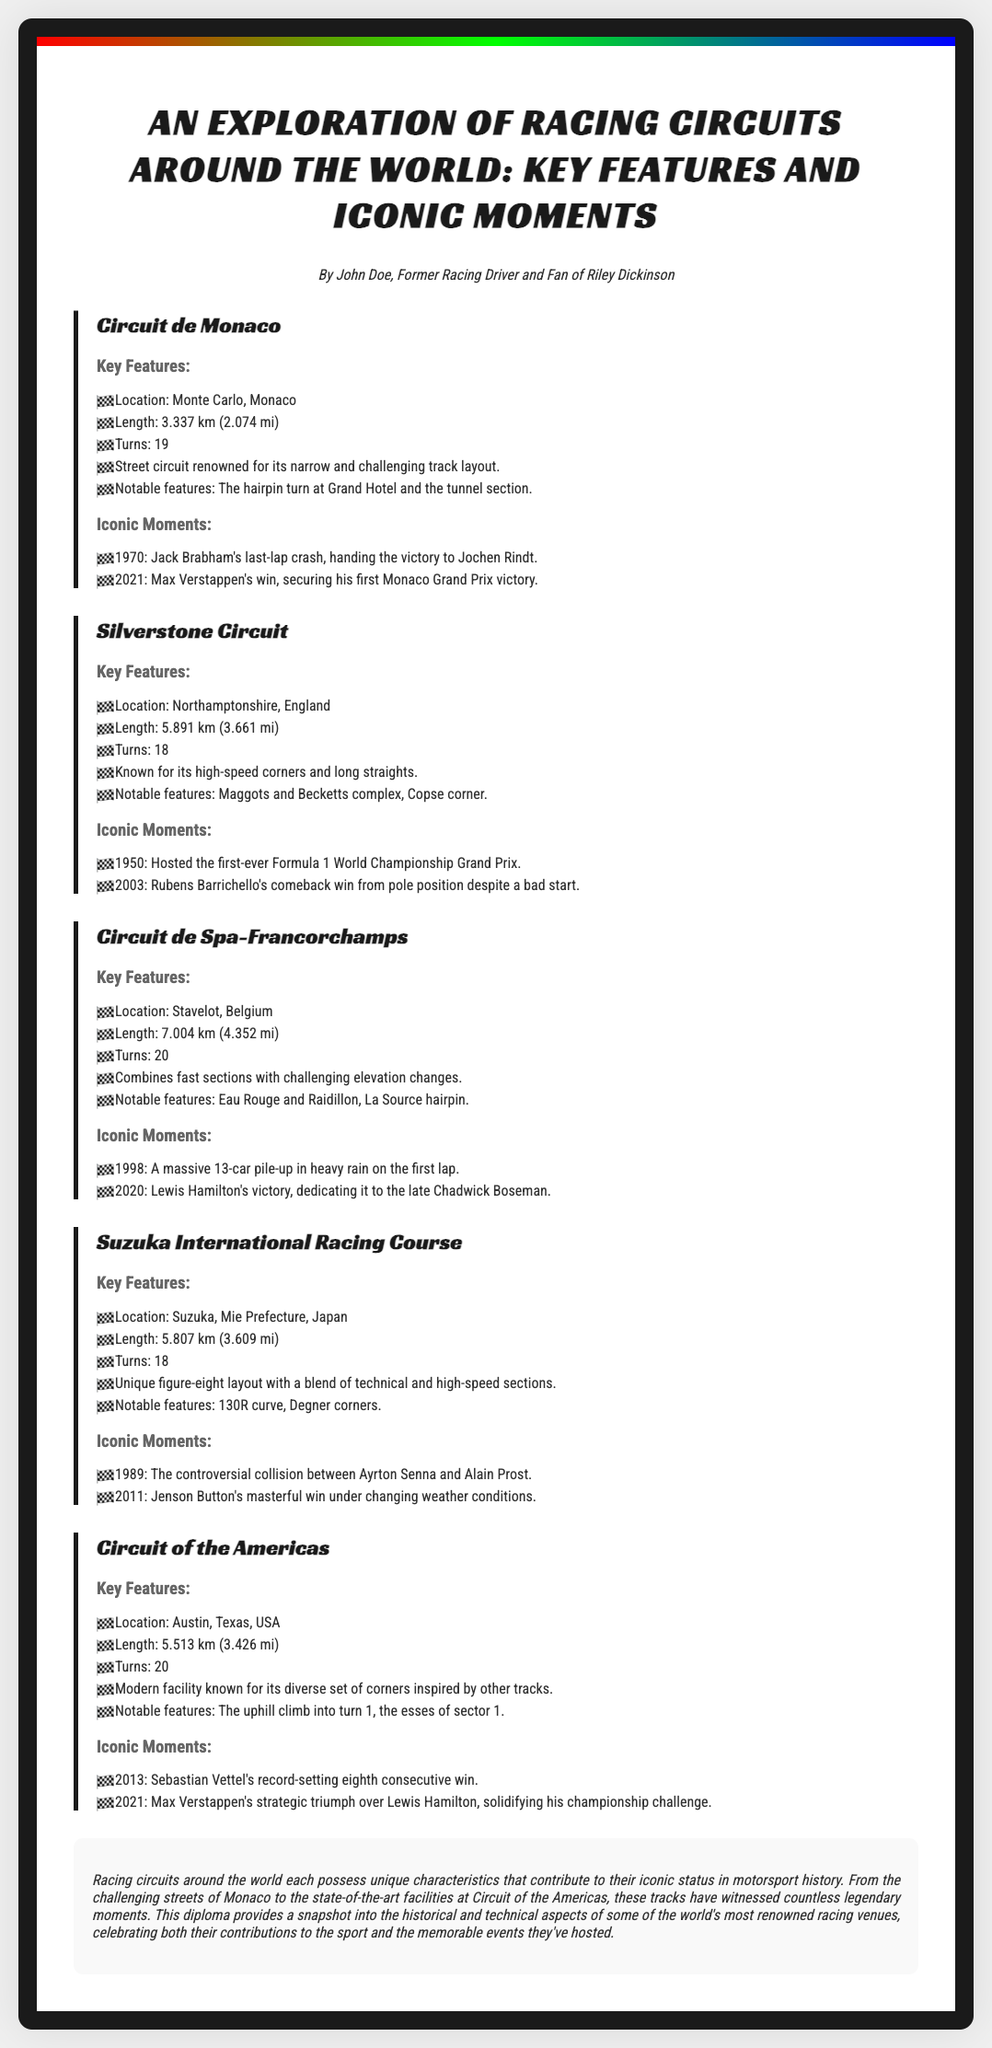what is the location of Circuit de Monaco? The location of Circuit de Monaco is mentioned in the document.
Answer: Monte Carlo, Monaco how long is the Silverstone Circuit? The document specifies the length of Silverstone Circuit.
Answer: 5.891 km (3.661 mi) which driver won the first-ever Formula 1 World Championship Grand Prix? The document states the iconic moment related to Silverstone Circuit.
Answer: Giuseppe Farina what year did Jenson Button win at Suzuka under changing weather conditions? The document lists Jenson Button's iconic moment at Suzuka International Racing Course.
Answer: 2011 what notable feature is associated with Eau Rouge and Raidillon? The document identifies these features in the context of Circuit de Spa-Francorchamps.
Answer: Notable features: Eau Rouge and Raidillon which circuit is known for its unique figure-eight layout? The document describes the circuit layout in the context of its key features.
Answer: Suzuka International Racing Course how many turns does Circuit of the Americas have? The number of turns for Circuit of the Americas is provided in the document.
Answer: 20 who secured his first Monaco Grand Prix victory in 2021? The document mentions a specific driver associated with an iconic moment at Circuit de Monaco.
Answer: Max Verstappen which circuit hosts the Maggots and Becketts complex? The document states the notable features of the Silverstone Circuit.
Answer: Silverstone Circuit 